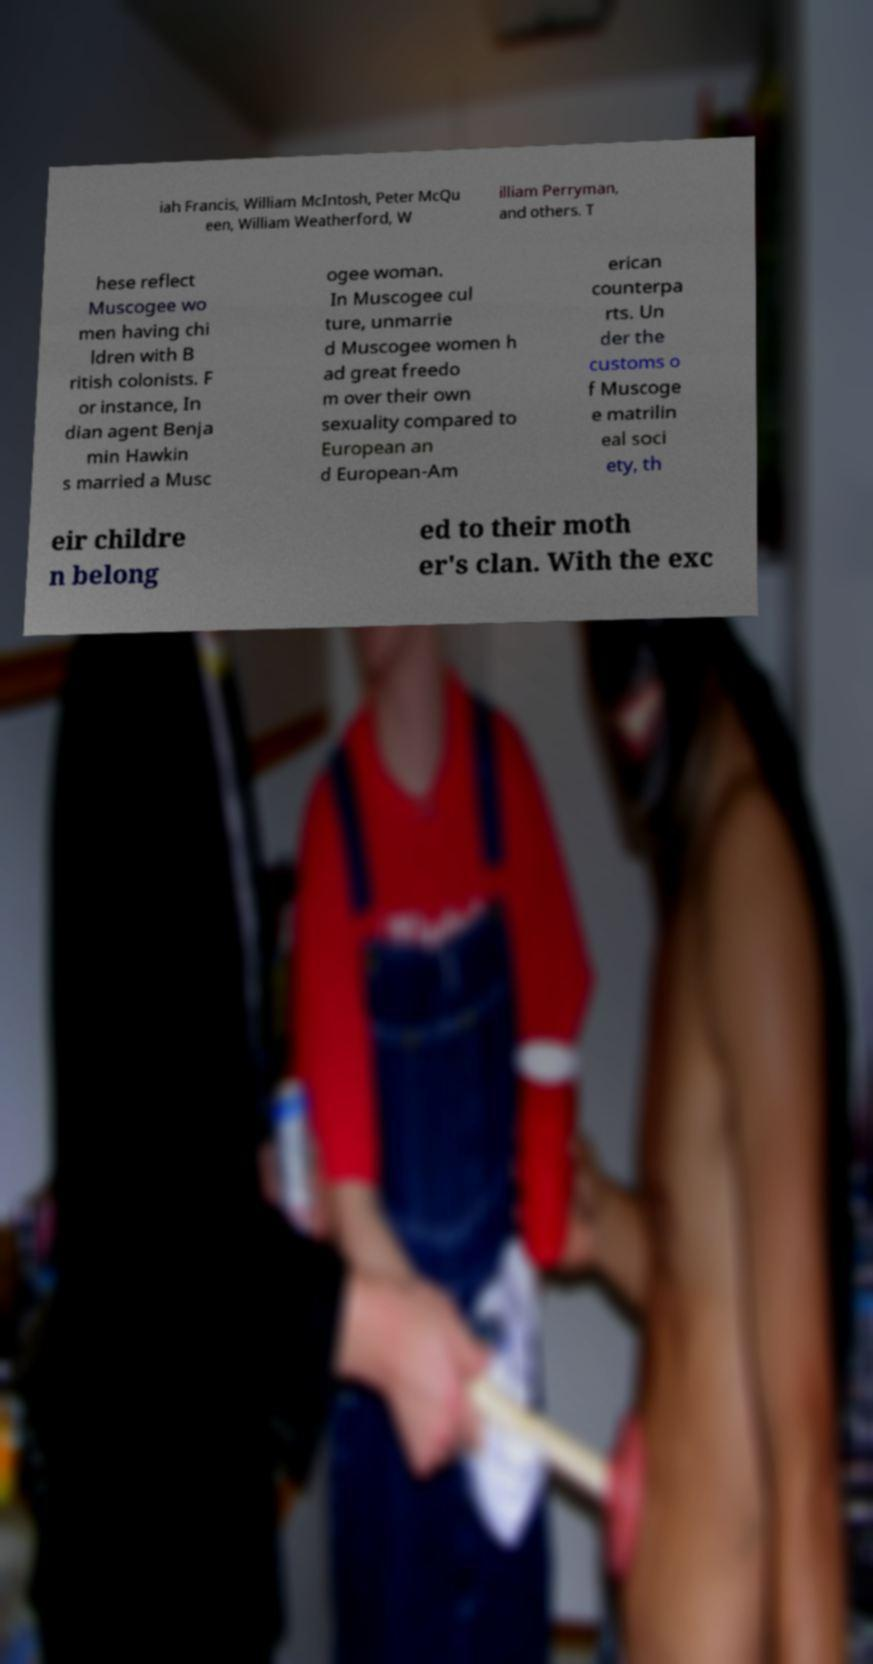Can you read and provide the text displayed in the image?This photo seems to have some interesting text. Can you extract and type it out for me? iah Francis, William McIntosh, Peter McQu een, William Weatherford, W illiam Perryman, and others. T hese reflect Muscogee wo men having chi ldren with B ritish colonists. F or instance, In dian agent Benja min Hawkin s married a Musc ogee woman. In Muscogee cul ture, unmarrie d Muscogee women h ad great freedo m over their own sexuality compared to European an d European-Am erican counterpa rts. Un der the customs o f Muscoge e matrilin eal soci ety, th eir childre n belong ed to their moth er's clan. With the exc 